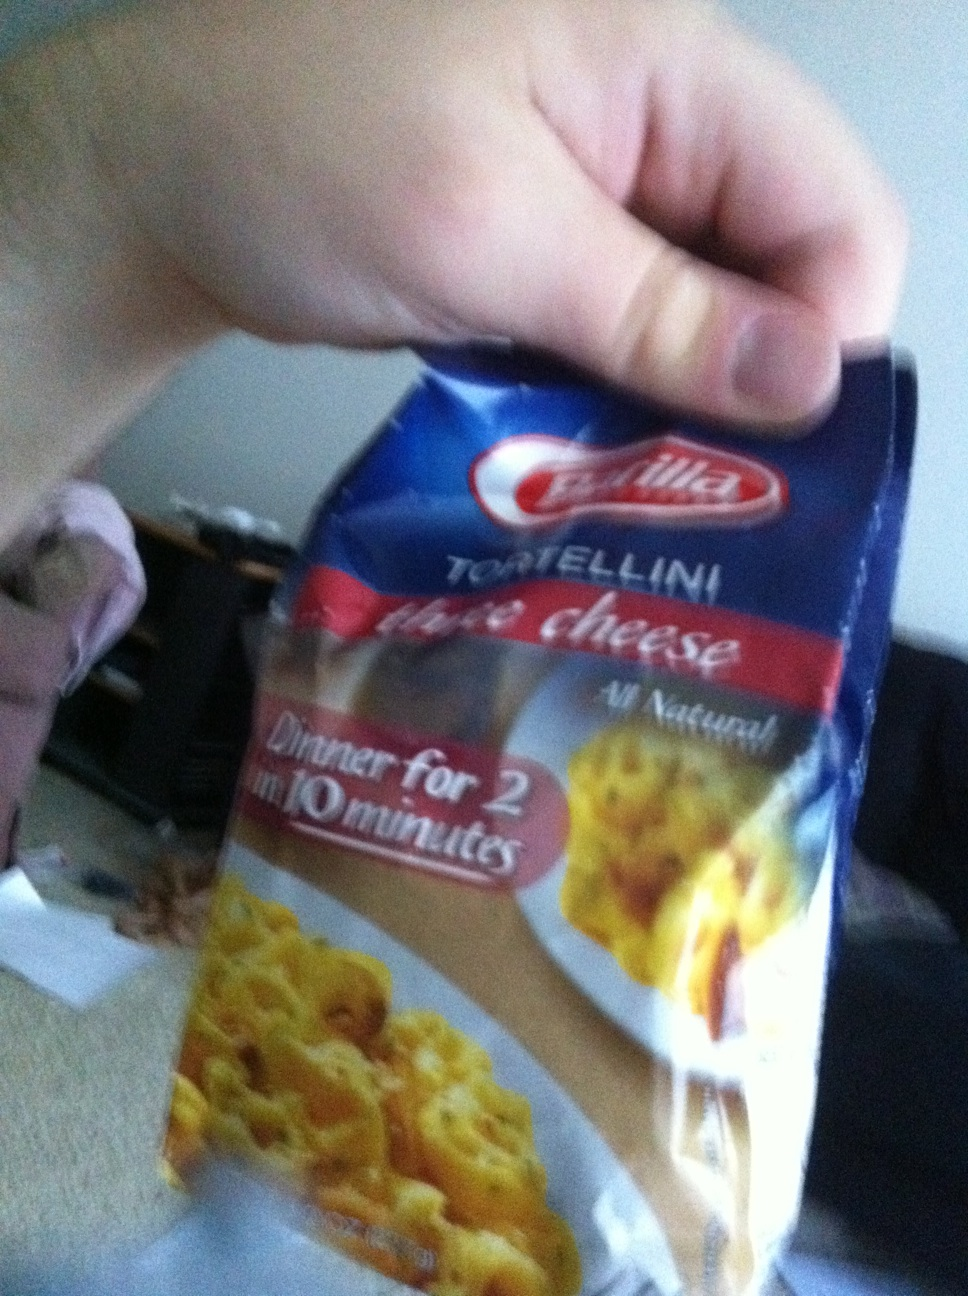Can this product be considered healthy? The healthiness of Barilla three cheese tortellini depends on your dietary preferences and needs. It is made with all-natural ingredients and contains a source of protein and calcium from the cheeses. However, it may be high in carbohydrates and sodium, so it's best enjoyed as part of a balanced diet. How would you suggest serving this tortellini for a nutritious meal? To create a nutritious meal using Barilla three cheese tortellini, you can serve it with a side of steamed vegetables such as broccoli or spinach, and a lean protein source like grilled chicken or shrimp. You might also consider adding a fresh salad with a light vinaigrette to balance the richness of the pasta. This combination can provide a variety of nutrients and create a satisfying dinner. 